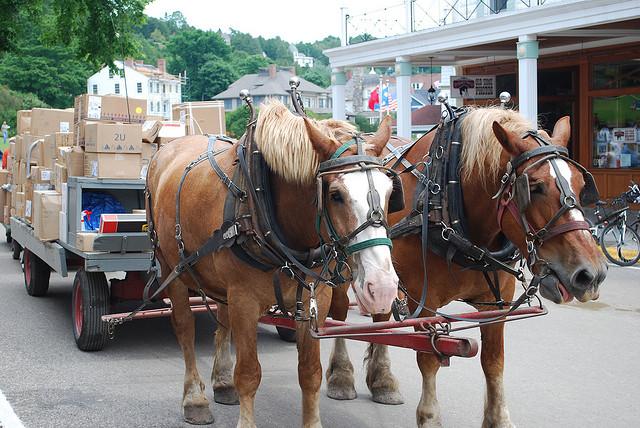What are the horses carrying?
Give a very brief answer. Boxes. How is the carriage attached to the horse?
Be succinct. Harness. How many horses are there?
Write a very short answer. 2. How is the red and brown box different from the others?
Give a very brief answer. Rest are brown. 